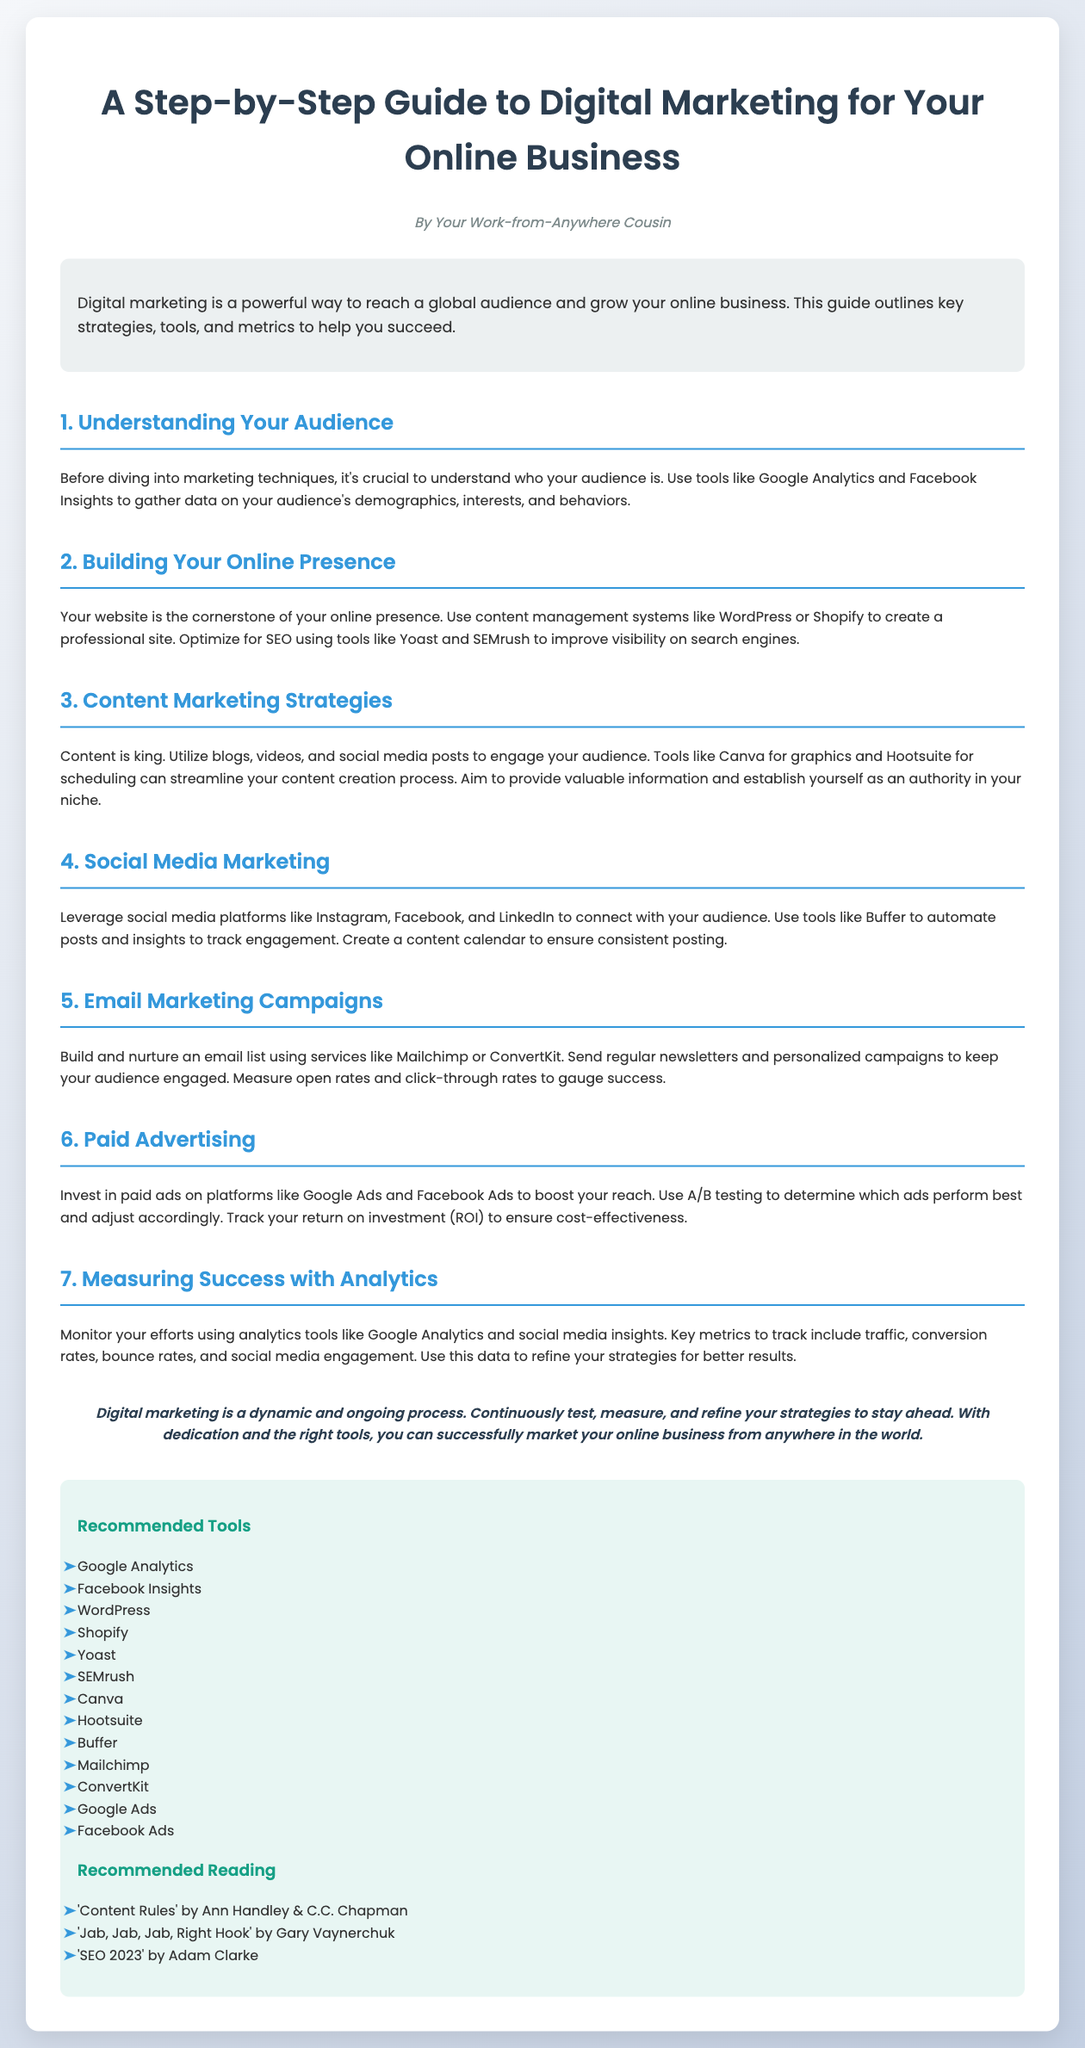What is the title of the guide? The title is explicitly stated at the beginning of the document.
Answer: A Step-by-Step Guide to Digital Marketing for Your Online Business Who is the author of the guide? The author is mentioned in the author section of the document.
Answer: Your Work-from-Anywhere Cousin What is the first section of the guide about? The first section discusses understanding one's audience, as outlined in the headings.
Answer: Understanding Your Audience What tool is recommended for measuring traffic? The document suggests using specific analytics tools for tracking metrics.
Answer: Google Analytics Which platform is suggested for building an online presence? The guide mentions particular content management systems for creating websites.
Answer: WordPress How many paid advertising platforms are mentioned? This information can be easily counted from the section covering paid advertising.
Answer: Two What is one of the metrics suggested for measuring success? The document lists multiple metrics that can be tracked for evaluating performance.
Answer: Conversion rates What role does content have in digital marketing according to the guide? The guide specifically emphasizes the importance of content in engaging audiences.
Answer: king Name one tool for social media post automation. The document provides specific tools for aiding in social media marketing efforts.
Answer: Buffer 